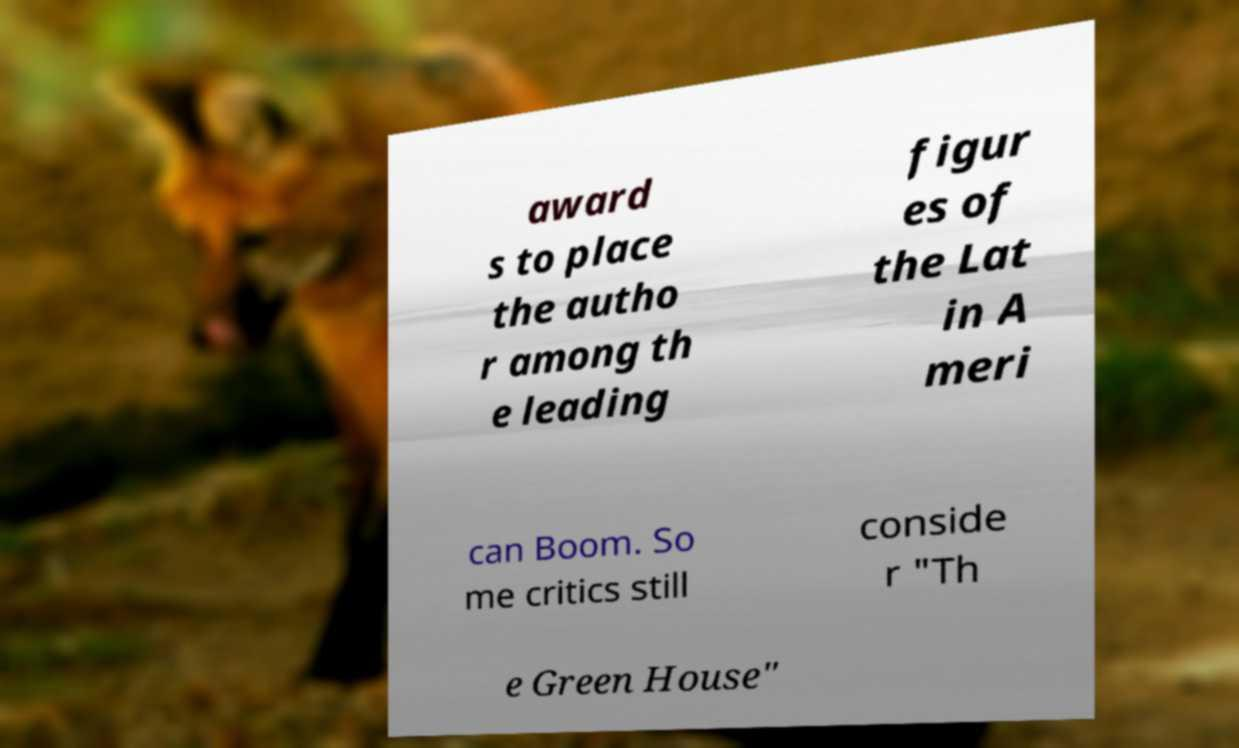Can you read and provide the text displayed in the image?This photo seems to have some interesting text. Can you extract and type it out for me? award s to place the autho r among th e leading figur es of the Lat in A meri can Boom. So me critics still conside r "Th e Green House" 